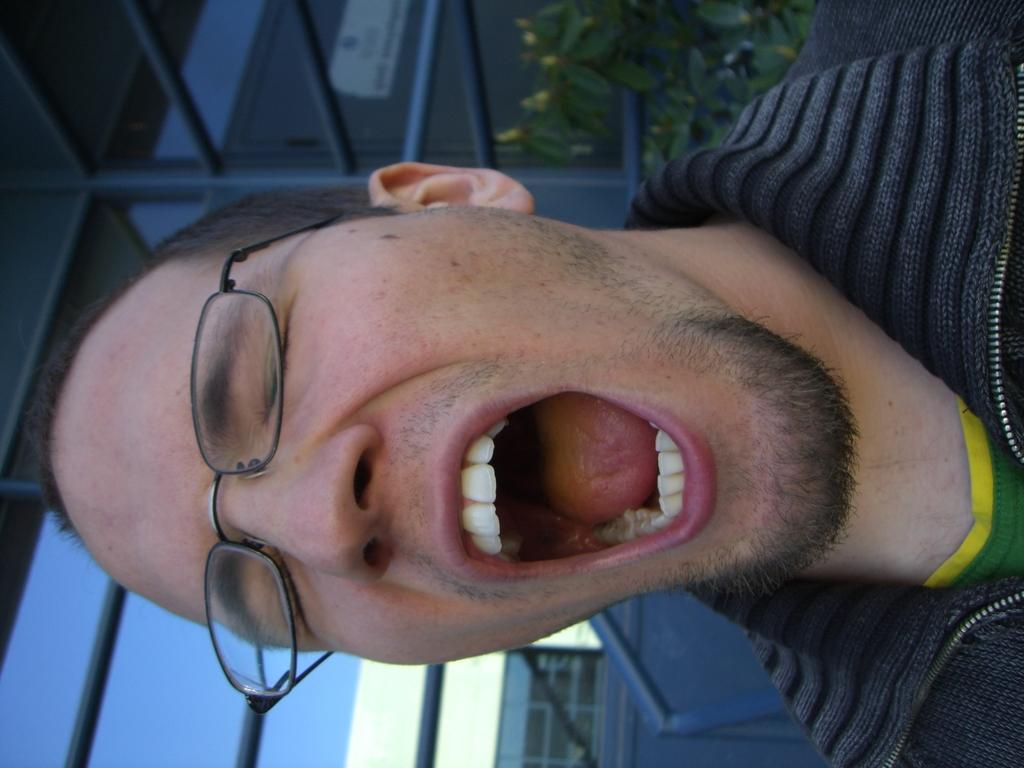What is the person in the image wearing? The person in the image is wearing a jacket. What can be seen in the background of the image? There are rods, buildings, plants, and the sky visible in the background of the image. Can you describe the setting of the image? The image appears to be set in an urban environment with buildings and rods in the background, along with plants and the sky. What type of hook can be seen in the image? There is no hook present in the image. How does the rainstorm affect the person in the image? There is no rainstorm present in the image, so it cannot affect the person. 